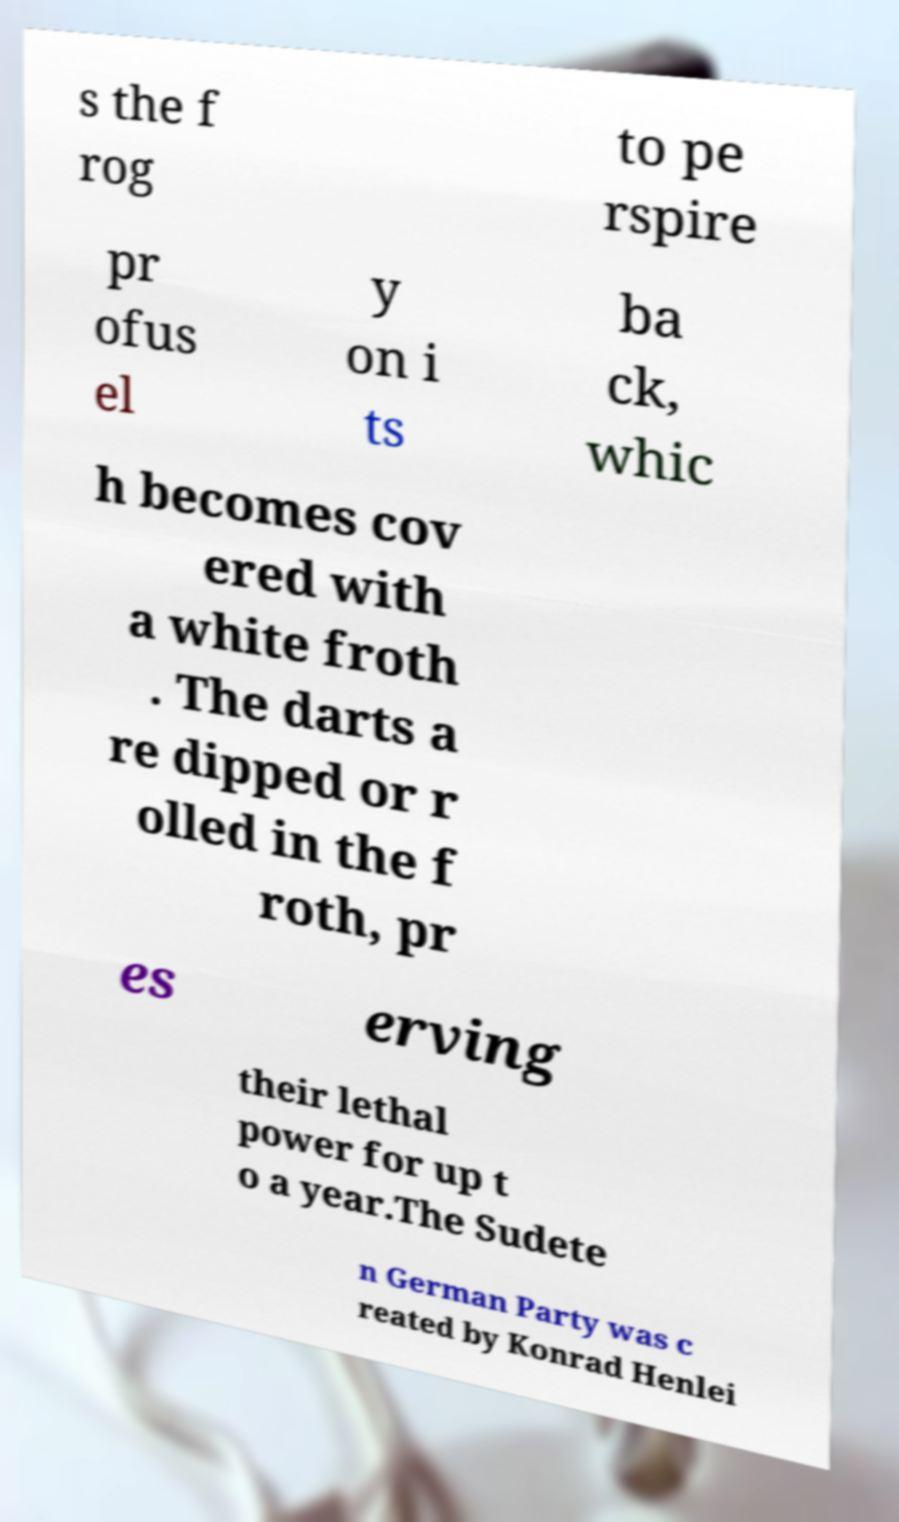Could you extract and type out the text from this image? s the f rog to pe rspire pr ofus el y on i ts ba ck, whic h becomes cov ered with a white froth . The darts a re dipped or r olled in the f roth, pr es erving their lethal power for up t o a year.The Sudete n German Party was c reated by Konrad Henlei 